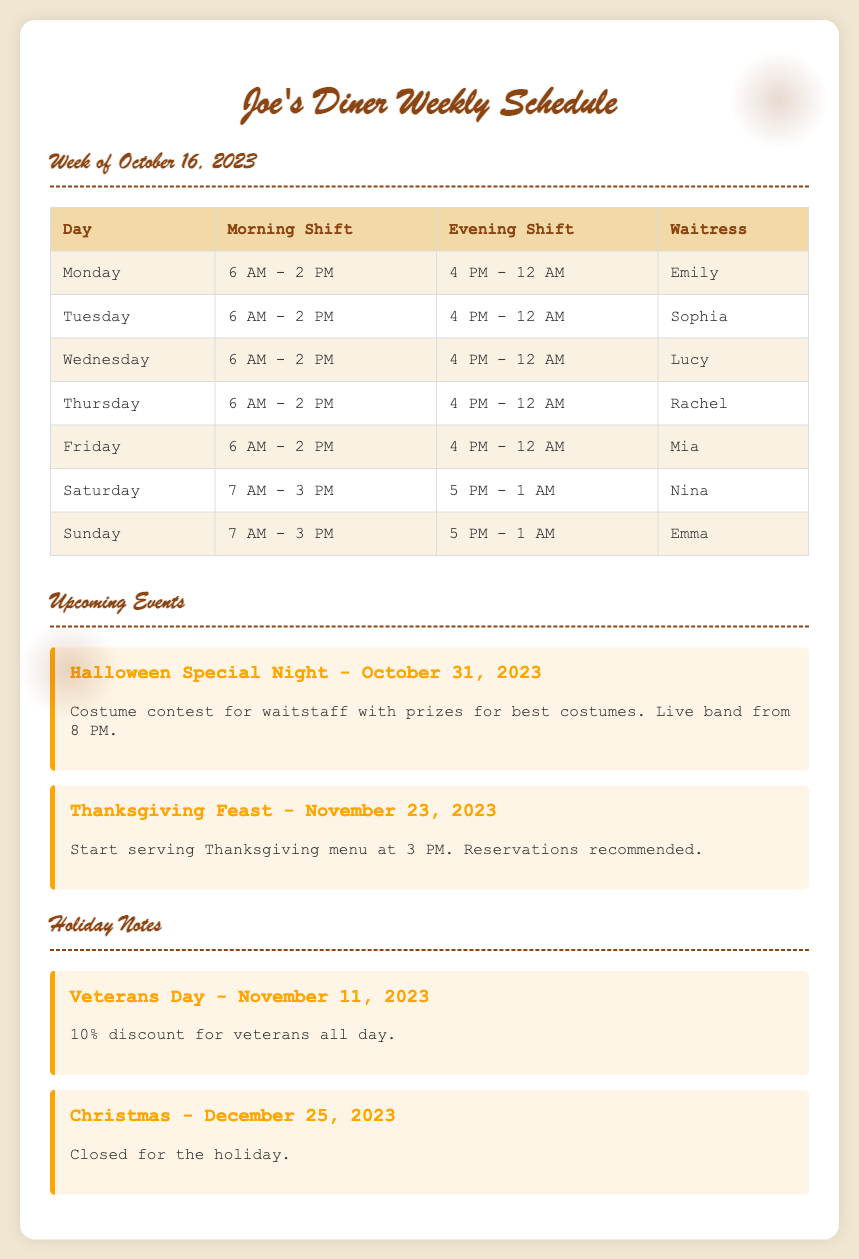What is the date range for the schedule? The schedule covers the week starting from October 16, 2023.
Answer: October 16, 2023 Who is the waitress on Wednesday? The document lists Lucy as the waitress for Wednesday.
Answer: Lucy What time does the evening shift start on Saturday? The schedule indicates that the evening shift on Saturday starts at 5 PM.
Answer: 5 PM What event takes place on Halloween? The document states there is a Halloween Special Night with a costume contest.
Answer: Halloween Special Night What is the discount offered for Veterans Day? The note specifies a 10% discount for veterans on Veterans Day.
Answer: 10% How many staff members are scheduled for the morning shift from Monday to Friday? By reviewing the schedule, it shows that there are 5 staff members scheduled for the morning shift from Monday to Friday.
Answer: 5 When does the Thanksgiving Feast start? The document indicates that the Thanksgiving Feast begins serving at 3 PM.
Answer: 3 PM What day is the diner closed for Christmas? The holiday notes mention that the diner is closed on December 25, 2023, for Christmas.
Answer: December 25, 2023 